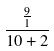Convert formula to latex. <formula><loc_0><loc_0><loc_500><loc_500>\frac { \frac { 9 } { 1 } } { 1 0 + 2 }</formula> 